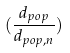<formula> <loc_0><loc_0><loc_500><loc_500>( \frac { d _ { p o p } } { d _ { p o p , n } } )</formula> 